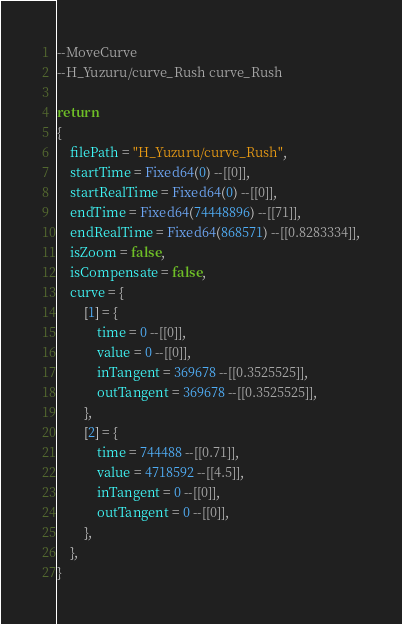Convert code to text. <code><loc_0><loc_0><loc_500><loc_500><_Lua_>--MoveCurve
--H_Yuzuru/curve_Rush curve_Rush

return
{
	filePath = "H_Yuzuru/curve_Rush",
	startTime = Fixed64(0) --[[0]],
	startRealTime = Fixed64(0) --[[0]],
	endTime = Fixed64(74448896) --[[71]],
	endRealTime = Fixed64(868571) --[[0.8283334]],
	isZoom = false,
	isCompensate = false,
	curve = {
		[1] = {
			time = 0 --[[0]],
			value = 0 --[[0]],
			inTangent = 369678 --[[0.3525525]],
			outTangent = 369678 --[[0.3525525]],
		},
		[2] = {
			time = 744488 --[[0.71]],
			value = 4718592 --[[4.5]],
			inTangent = 0 --[[0]],
			outTangent = 0 --[[0]],
		},
	},
}</code> 